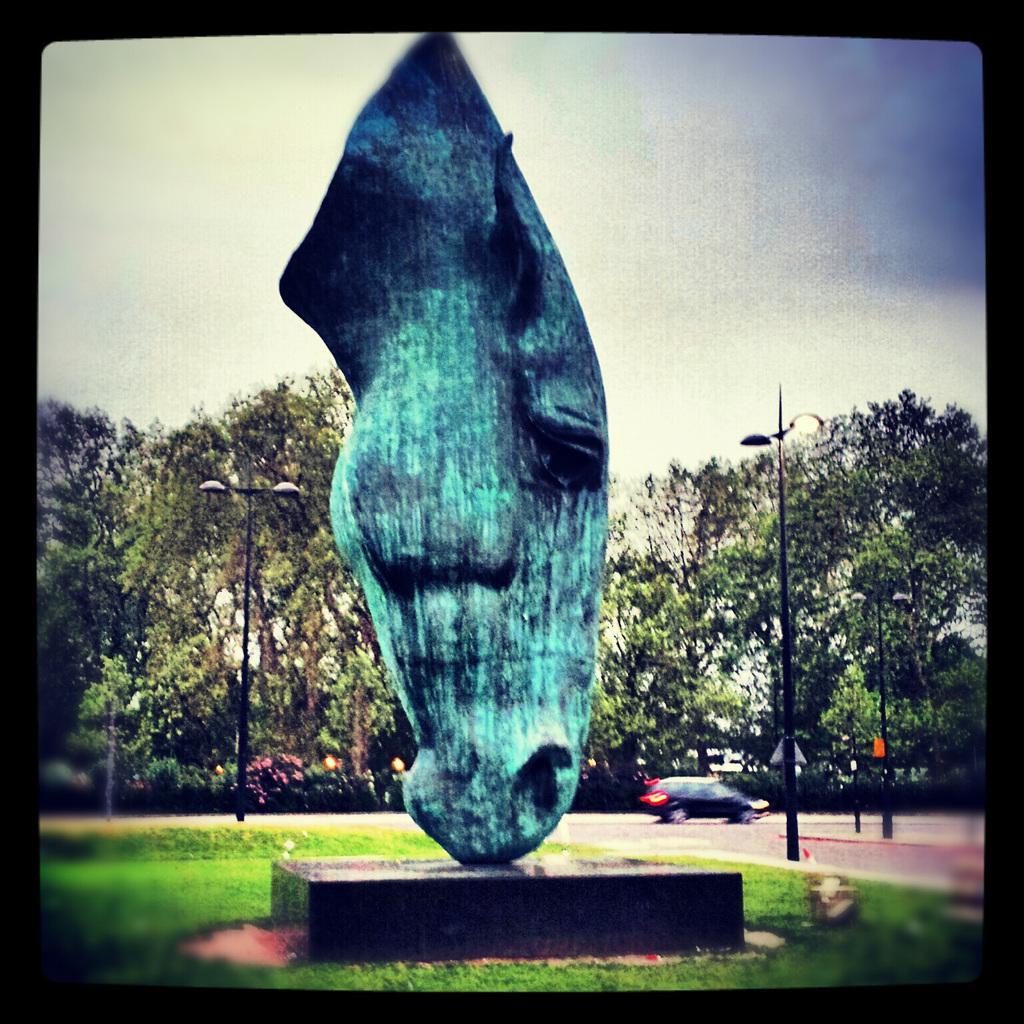Please provide a concise description of this image. In this image in the center there is one sculpture, at the bottom there is grass and in the background there are some trees, poles and street lights. On the top of the image there is sky and in the center there is one car. 